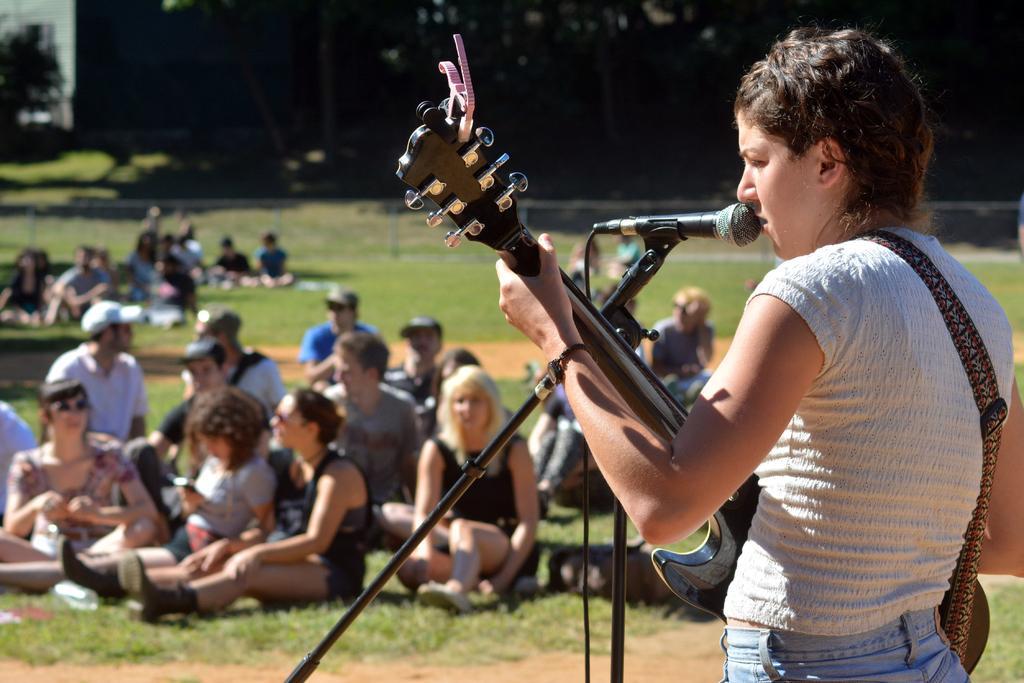Could you give a brief overview of what you see in this image? In this image, on the right side, we can see a person standing and holding a guitar, there is a microphone. We can see some people sitting on the grass. 